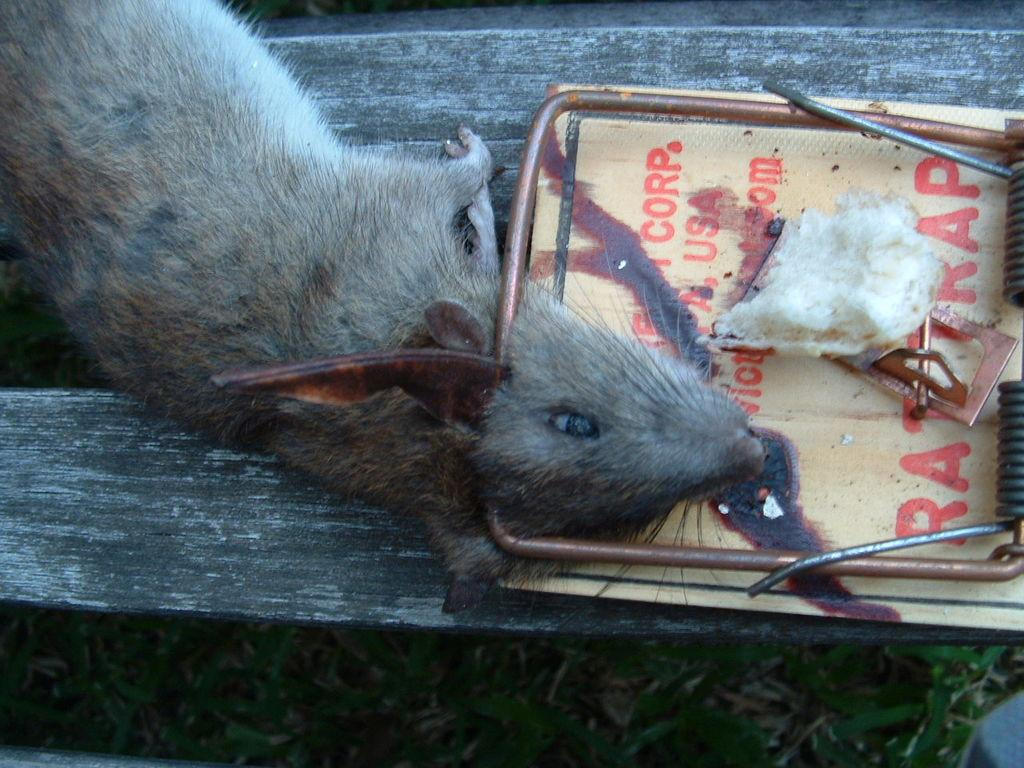What animal is present in the image? There is a rat in the image. What is the rat's current situation? The rat is in a rat trap. What type of environment can be seen in the background of the image? There is grass visible in the background of the image. What type of cover is the rat using to protect itself from the rain in the image? There is no cover present in the image, and it is not raining. The rat is in a rat trap. 